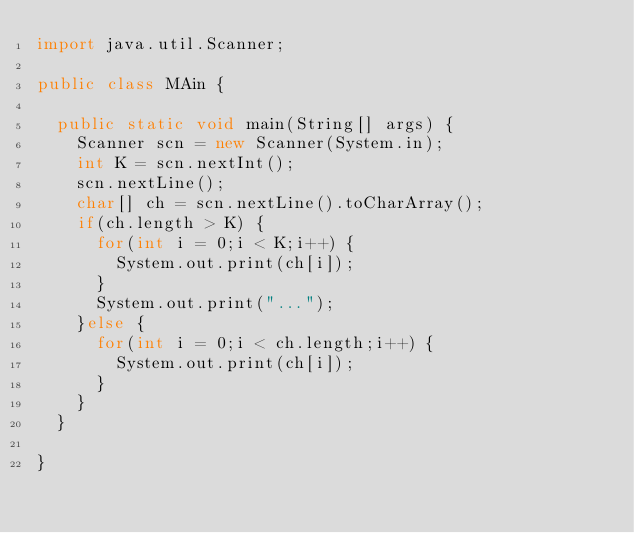<code> <loc_0><loc_0><loc_500><loc_500><_Java_>import java.util.Scanner;

public class MAin {

	public static void main(String[] args) {
		Scanner scn = new Scanner(System.in);
		int K = scn.nextInt();
		scn.nextLine();
		char[] ch = scn.nextLine().toCharArray();
		if(ch.length > K) {
			for(int i = 0;i < K;i++) {
				System.out.print(ch[i]);
			}
			System.out.print("...");
		}else {
			for(int i = 0;i < ch.length;i++) {
				System.out.print(ch[i]);
			}
		}
	}

}
</code> 